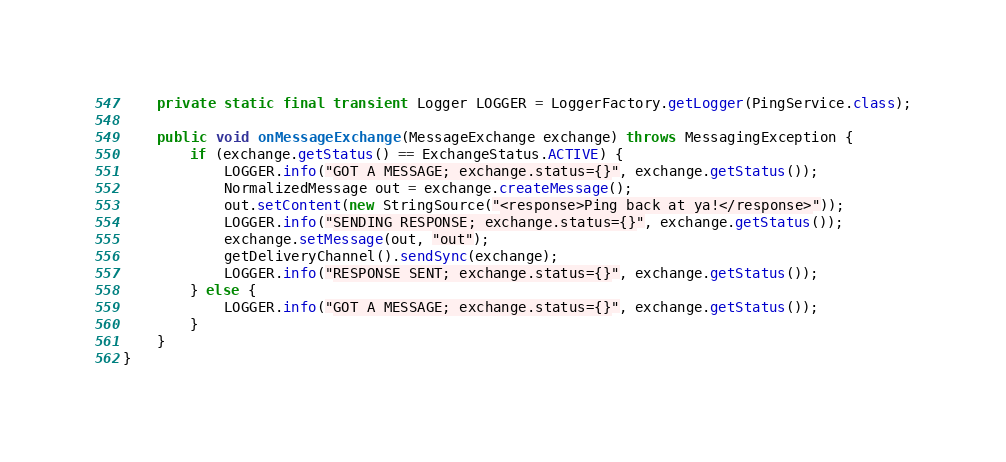<code> <loc_0><loc_0><loc_500><loc_500><_Java_>
    private static final transient Logger LOGGER = LoggerFactory.getLogger(PingService.class);

    public void onMessageExchange(MessageExchange exchange) throws MessagingException {
        if (exchange.getStatus() == ExchangeStatus.ACTIVE) {
            LOGGER.info("GOT A MESSAGE; exchange.status={}", exchange.getStatus());
            NormalizedMessage out = exchange.createMessage();
            out.setContent(new StringSource("<response>Ping back at ya!</response>"));
            LOGGER.info("SENDING RESPONSE; exchange.status={}", exchange.getStatus());
            exchange.setMessage(out, "out");
            getDeliveryChannel().sendSync(exchange);
            LOGGER.info("RESPONSE SENT; exchange.status={}", exchange.getStatus());
        } else {
            LOGGER.info("GOT A MESSAGE; exchange.status={}", exchange.getStatus());
        }
    }
}</code> 